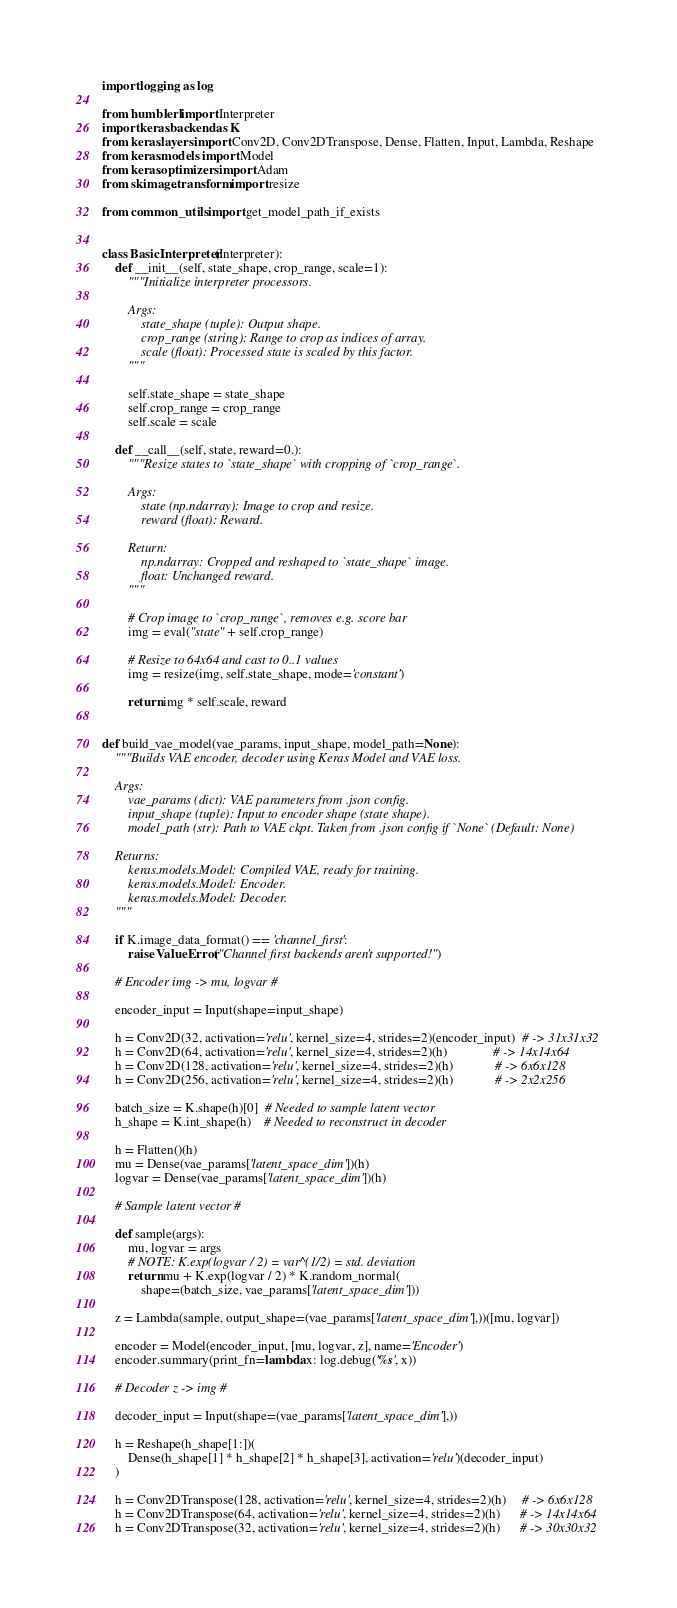<code> <loc_0><loc_0><loc_500><loc_500><_Python_>import logging as log

from humblerl import Interpreter
import keras.backend as K
from keras.layers import Conv2D, Conv2DTranspose, Dense, Flatten, Input, Lambda, Reshape
from keras.models import Model
from keras.optimizers import Adam
from skimage.transform import resize

from common_utils import get_model_path_if_exists


class BasicInterpreter(Interpreter):
    def __init__(self, state_shape, crop_range, scale=1):
        """Initialize interpreter processors.

        Args:
            state_shape (tuple): Output shape.
            crop_range (string): Range to crop as indices of array.
            scale (float): Processed state is scaled by this factor.
        """

        self.state_shape = state_shape
        self.crop_range = crop_range
        self.scale = scale

    def __call__(self, state, reward=0.):
        """Resize states to `state_shape` with cropping of `crop_range`.

        Args:
            state (np.ndarray): Image to crop and resize.
            reward (float): Reward.

        Return:
            np.ndarray: Cropped and reshaped to `state_shape` image.
            float: Unchanged reward.
        """

        # Crop image to `crop_range`, removes e.g. score bar
        img = eval("state" + self.crop_range)

        # Resize to 64x64 and cast to 0..1 values
        img = resize(img, self.state_shape, mode='constant')

        return img * self.scale, reward


def build_vae_model(vae_params, input_shape, model_path=None):
    """Builds VAE encoder, decoder using Keras Model and VAE loss.

    Args:
        vae_params (dict): VAE parameters from .json config.
        input_shape (tuple): Input to encoder shape (state shape).
        model_path (str): Path to VAE ckpt. Taken from .json config if `None` (Default: None)

    Returns:
        keras.models.Model: Compiled VAE, ready for training.
        keras.models.Model: Encoder.
        keras.models.Model: Decoder.
    """

    if K.image_data_format() == 'channel_first':
        raise ValueError("Channel first backends aren't supported!")

    # Encoder img -> mu, logvar #

    encoder_input = Input(shape=input_shape)

    h = Conv2D(32, activation='relu', kernel_size=4, strides=2)(encoder_input)  # -> 31x31x32
    h = Conv2D(64, activation='relu', kernel_size=4, strides=2)(h)              # -> 14x14x64
    h = Conv2D(128, activation='relu', kernel_size=4, strides=2)(h)             # -> 6x6x128
    h = Conv2D(256, activation='relu', kernel_size=4, strides=2)(h)             # -> 2x2x256

    batch_size = K.shape(h)[0]  # Needed to sample latent vector
    h_shape = K.int_shape(h)    # Needed to reconstruct in decoder

    h = Flatten()(h)
    mu = Dense(vae_params['latent_space_dim'])(h)
    logvar = Dense(vae_params['latent_space_dim'])(h)

    # Sample latent vector #

    def sample(args):
        mu, logvar = args
        # NOTE: K.exp(logvar / 2) = var^(1/2) = std. deviation
        return mu + K.exp(logvar / 2) * K.random_normal(
            shape=(batch_size, vae_params['latent_space_dim']))

    z = Lambda(sample, output_shape=(vae_params['latent_space_dim'],))([mu, logvar])

    encoder = Model(encoder_input, [mu, logvar, z], name='Encoder')
    encoder.summary(print_fn=lambda x: log.debug('%s', x))

    # Decoder z -> img #

    decoder_input = Input(shape=(vae_params['latent_space_dim'],))

    h = Reshape(h_shape[1:])(
        Dense(h_shape[1] * h_shape[2] * h_shape[3], activation='relu')(decoder_input)
    )

    h = Conv2DTranspose(128, activation='relu', kernel_size=4, strides=2)(h)     # -> 6x6x128
    h = Conv2DTranspose(64, activation='relu', kernel_size=4, strides=2)(h)      # -> 14x14x64
    h = Conv2DTranspose(32, activation='relu', kernel_size=4, strides=2)(h)      # -> 30x30x32</code> 